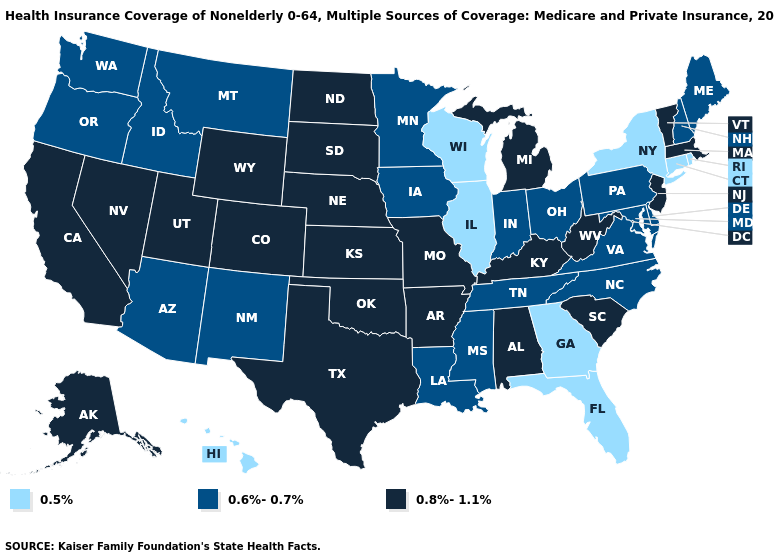Name the states that have a value in the range 0.6%-0.7%?
Short answer required. Arizona, Delaware, Idaho, Indiana, Iowa, Louisiana, Maine, Maryland, Minnesota, Mississippi, Montana, New Hampshire, New Mexico, North Carolina, Ohio, Oregon, Pennsylvania, Tennessee, Virginia, Washington. Name the states that have a value in the range 0.5%?
Keep it brief. Connecticut, Florida, Georgia, Hawaii, Illinois, New York, Rhode Island, Wisconsin. Does the first symbol in the legend represent the smallest category?
Be succinct. Yes. What is the lowest value in the MidWest?
Short answer required. 0.5%. How many symbols are there in the legend?
Write a very short answer. 3. Does California have the lowest value in the West?
Keep it brief. No. What is the highest value in the USA?
Quick response, please. 0.8%-1.1%. Among the states that border New Mexico , does Oklahoma have the lowest value?
Keep it brief. No. Is the legend a continuous bar?
Answer briefly. No. What is the value of Alaska?
Concise answer only. 0.8%-1.1%. Name the states that have a value in the range 0.8%-1.1%?
Write a very short answer. Alabama, Alaska, Arkansas, California, Colorado, Kansas, Kentucky, Massachusetts, Michigan, Missouri, Nebraska, Nevada, New Jersey, North Dakota, Oklahoma, South Carolina, South Dakota, Texas, Utah, Vermont, West Virginia, Wyoming. Does the map have missing data?
Quick response, please. No. Name the states that have a value in the range 0.6%-0.7%?
Give a very brief answer. Arizona, Delaware, Idaho, Indiana, Iowa, Louisiana, Maine, Maryland, Minnesota, Mississippi, Montana, New Hampshire, New Mexico, North Carolina, Ohio, Oregon, Pennsylvania, Tennessee, Virginia, Washington. Does Alabama have the same value as Arizona?
Concise answer only. No. Does Georgia have the highest value in the USA?
Short answer required. No. 